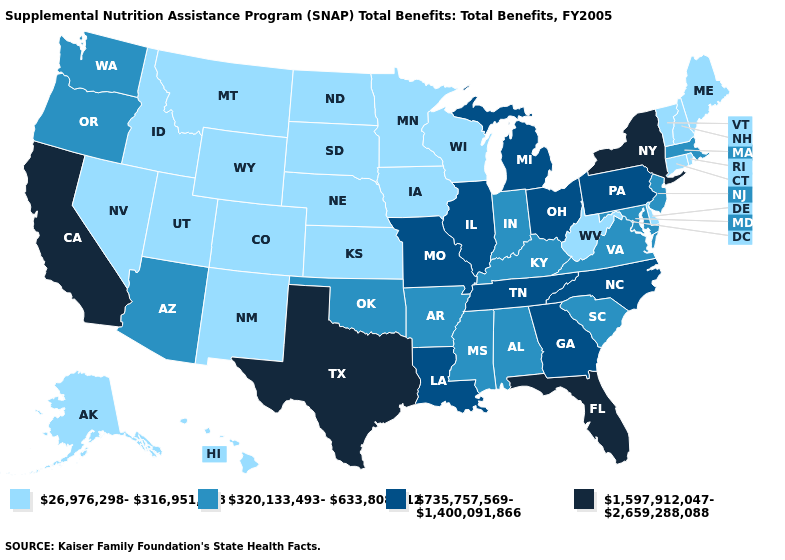Name the states that have a value in the range 320,133,493-633,808,912?
Quick response, please. Alabama, Arizona, Arkansas, Indiana, Kentucky, Maryland, Massachusetts, Mississippi, New Jersey, Oklahoma, Oregon, South Carolina, Virginia, Washington. Is the legend a continuous bar?
Be succinct. No. Does the map have missing data?
Answer briefly. No. Which states have the lowest value in the USA?
Answer briefly. Alaska, Colorado, Connecticut, Delaware, Hawaii, Idaho, Iowa, Kansas, Maine, Minnesota, Montana, Nebraska, Nevada, New Hampshire, New Mexico, North Dakota, Rhode Island, South Dakota, Utah, Vermont, West Virginia, Wisconsin, Wyoming. Does Pennsylvania have the highest value in the USA?
Keep it brief. No. Among the states that border Idaho , which have the lowest value?
Give a very brief answer. Montana, Nevada, Utah, Wyoming. Does Rhode Island have the same value as Illinois?
Write a very short answer. No. Does New Mexico have the same value as Oregon?
Quick response, please. No. What is the lowest value in states that border Alabama?
Give a very brief answer. 320,133,493-633,808,912. What is the value of California?
Be succinct. 1,597,912,047-2,659,288,088. What is the highest value in the Northeast ?
Give a very brief answer. 1,597,912,047-2,659,288,088. Does the map have missing data?
Give a very brief answer. No. What is the value of Montana?
Keep it brief. 26,976,298-316,951,818. What is the value of West Virginia?
Keep it brief. 26,976,298-316,951,818. Is the legend a continuous bar?
Be succinct. No. 